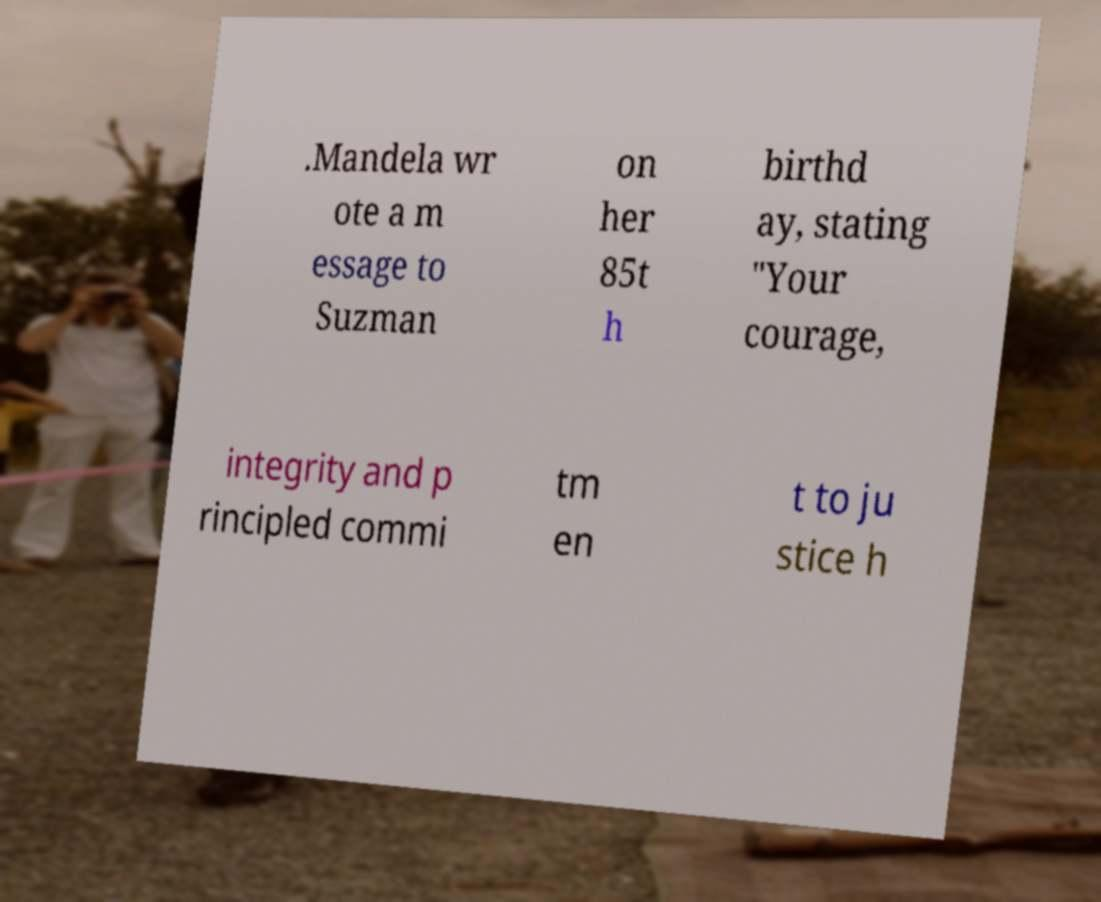Please identify and transcribe the text found in this image. .Mandela wr ote a m essage to Suzman on her 85t h birthd ay, stating "Your courage, integrity and p rincipled commi tm en t to ju stice h 